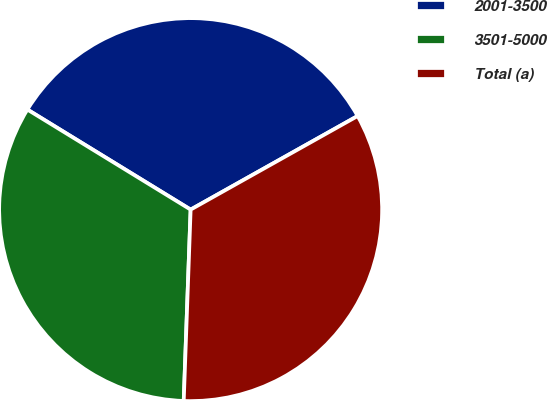Convert chart to OTSL. <chart><loc_0><loc_0><loc_500><loc_500><pie_chart><fcel>2001-3500<fcel>3501-5000<fcel>Total (a)<nl><fcel>33.12%<fcel>33.18%<fcel>33.71%<nl></chart> 